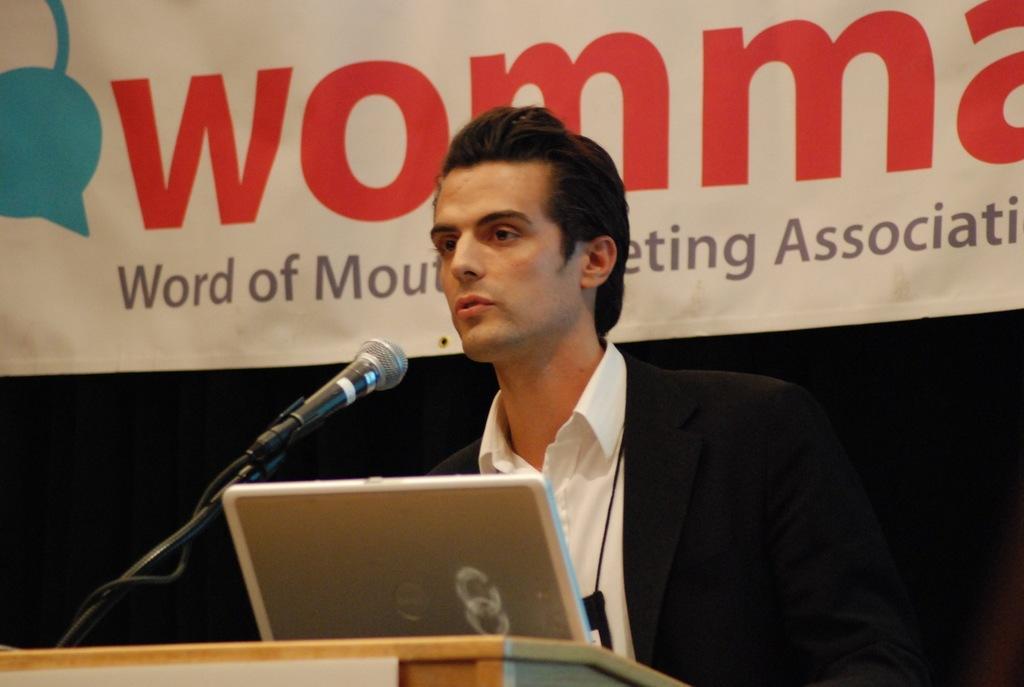Can you describe this image briefly? In this image I can see a person wearing a suit and an id card. There is a banner at the back and there is a laptop and a microphone in the front. 